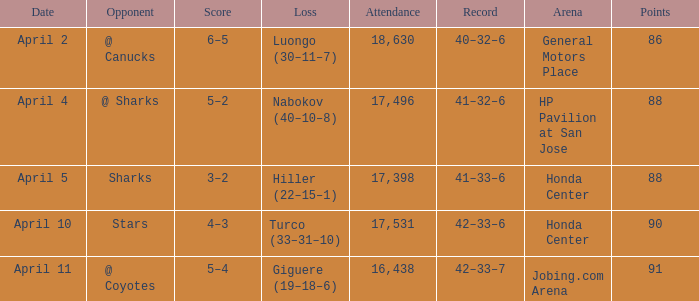Which Loss has a Record of 41–32–6? Nabokov (40–10–8). 